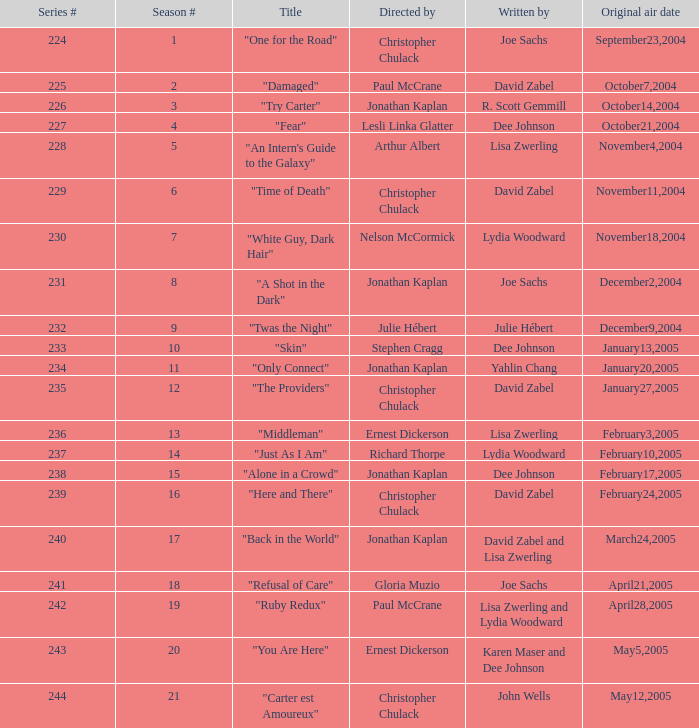Name the title that was written by r. scott gemmill "Try Carter". 